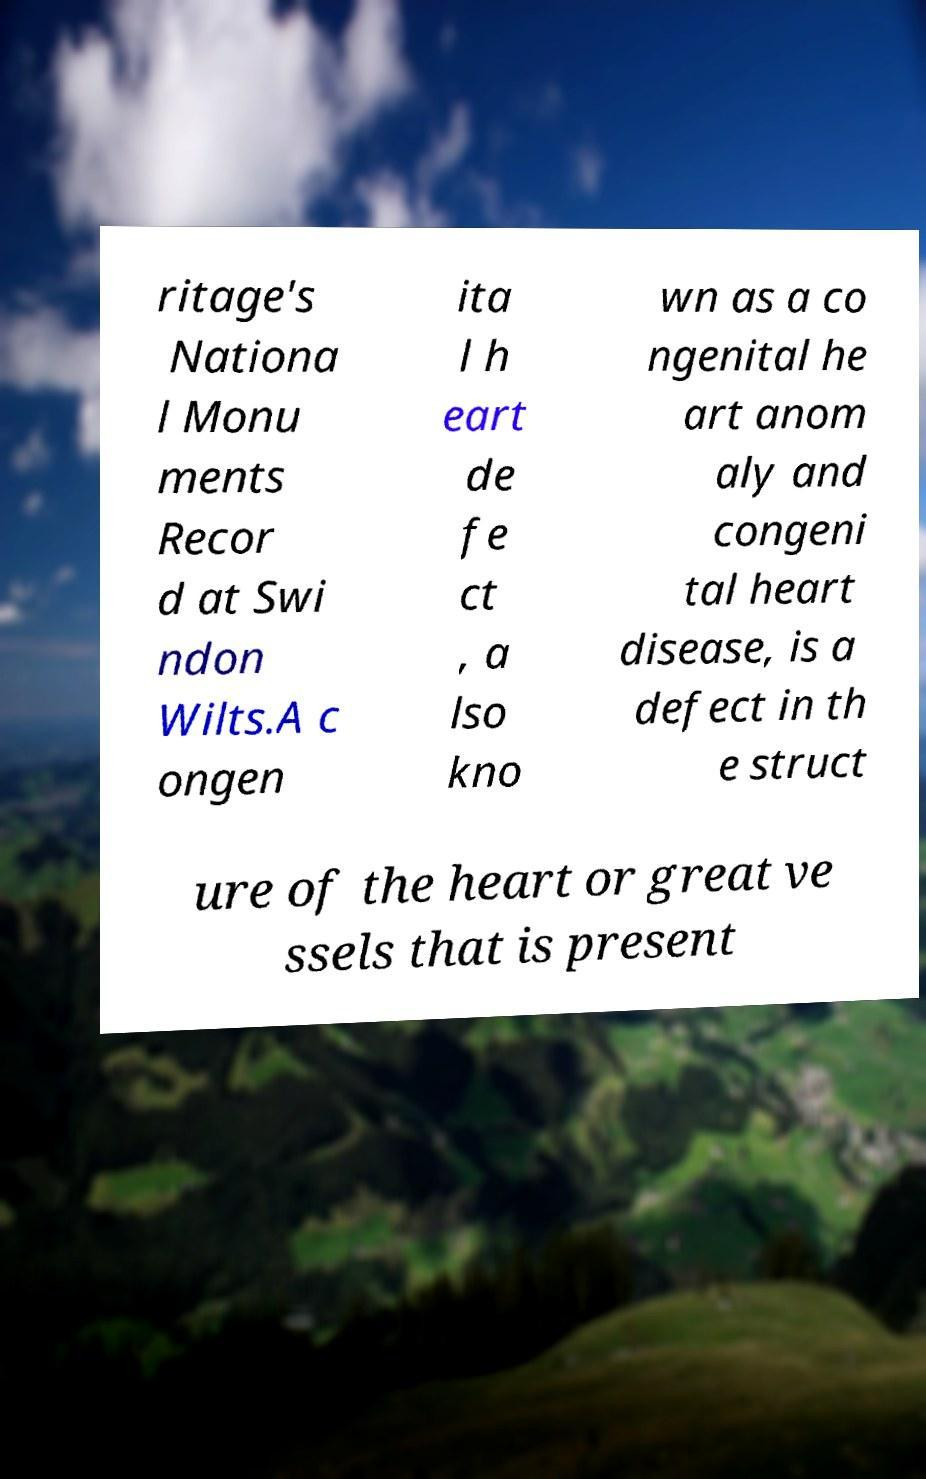Can you accurately transcribe the text from the provided image for me? ritage's Nationa l Monu ments Recor d at Swi ndon Wilts.A c ongen ita l h eart de fe ct , a lso kno wn as a co ngenital he art anom aly and congeni tal heart disease, is a defect in th e struct ure of the heart or great ve ssels that is present 